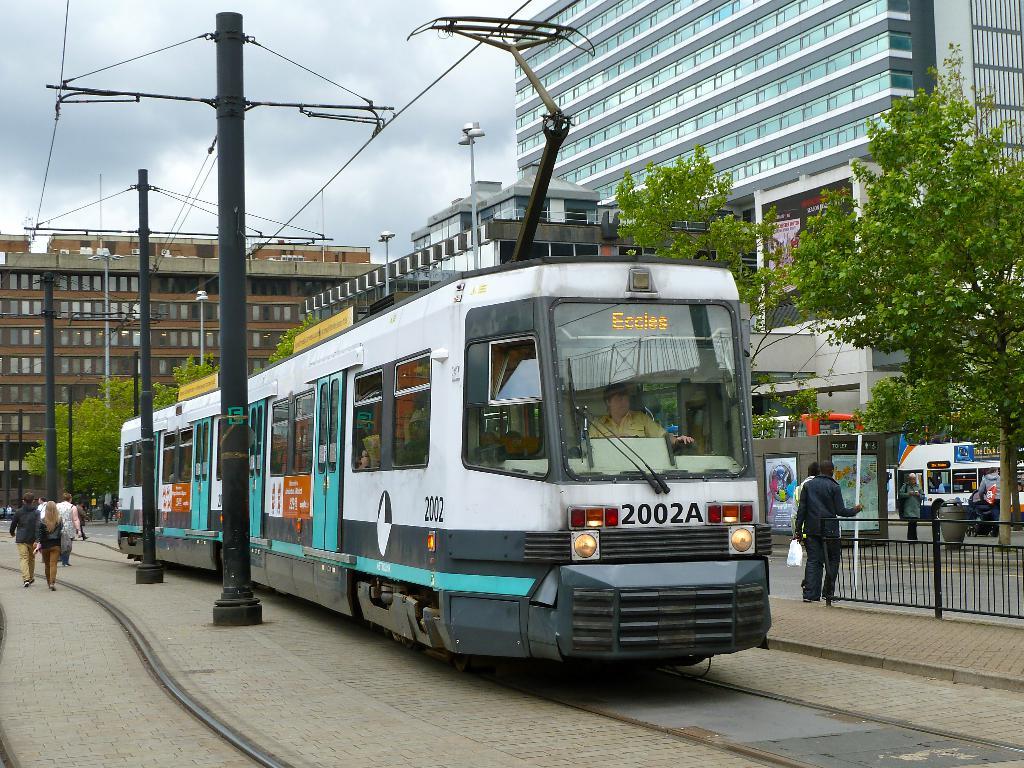What number is on the bus?
Offer a terse response. 2002a. What is the train number?
Offer a terse response. 2002a. 